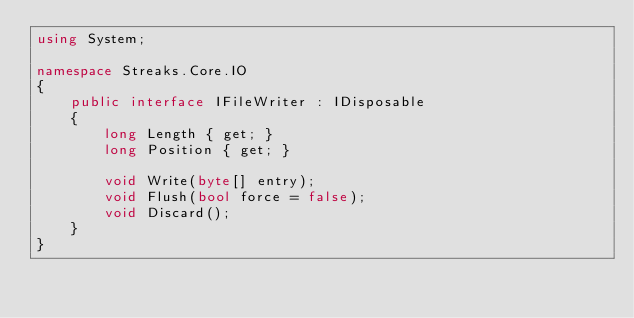Convert code to text. <code><loc_0><loc_0><loc_500><loc_500><_C#_>using System;

namespace Streaks.Core.IO
{
    public interface IFileWriter : IDisposable
    {
        long Length { get; }
        long Position { get; }

        void Write(byte[] entry);
        void Flush(bool force = false);
        void Discard();
    }
}</code> 